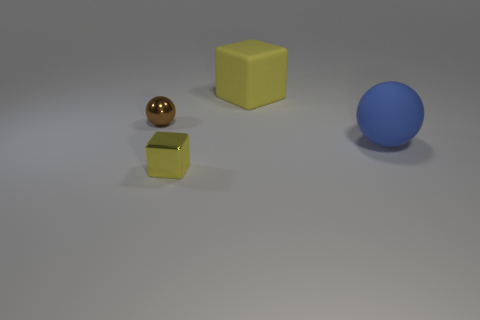Do the blue rubber object and the brown thing have the same shape?
Provide a short and direct response. Yes. What color is the object that is to the left of the yellow rubber thing and right of the metal sphere?
Provide a succinct answer. Yellow. What is the size of the other matte cube that is the same color as the small cube?
Offer a very short reply. Large. How many small objects are either blue shiny blocks or yellow matte things?
Make the answer very short. 0. Are there any other things of the same color as the large block?
Ensure brevity in your answer.  Yes. What is the material of the tiny thing behind the big matte thing in front of the small shiny object that is behind the small yellow metal thing?
Your answer should be compact. Metal. How many metal things are either large cubes or large blue objects?
Your answer should be compact. 0. How many blue objects are big objects or large blocks?
Ensure brevity in your answer.  1. There is a block on the left side of the big yellow matte block; is its color the same as the matte cube?
Your response must be concise. Yes. Does the big yellow thing have the same material as the large blue object?
Give a very brief answer. Yes. 